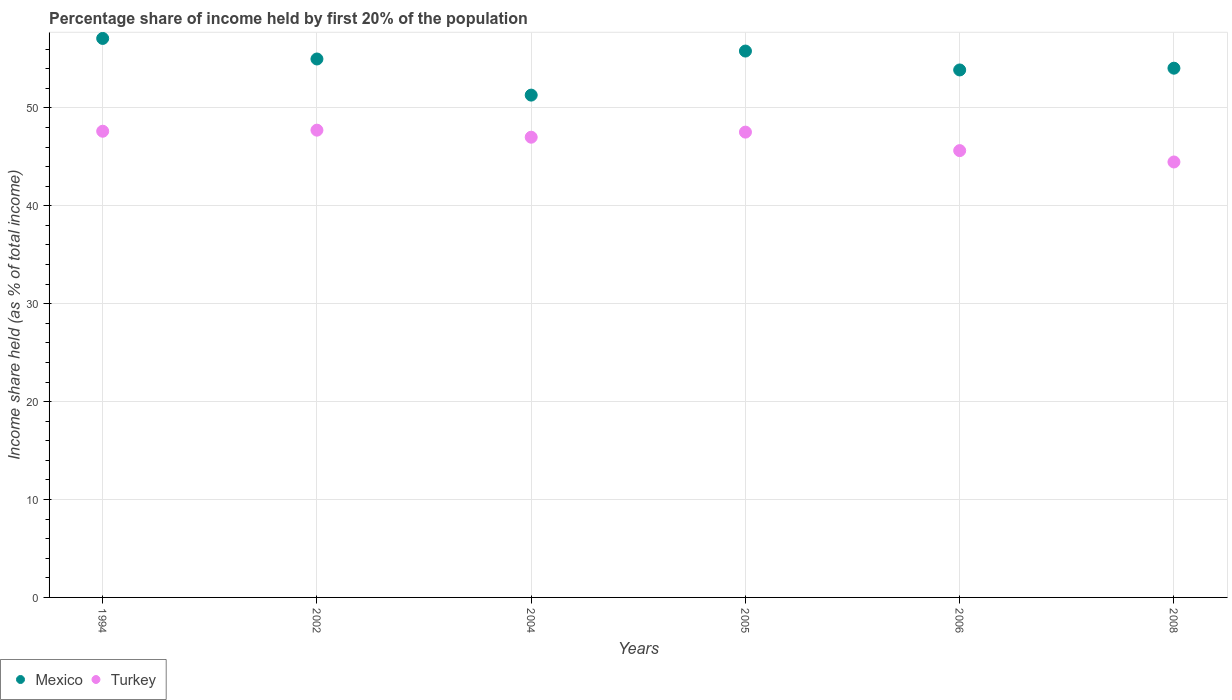Is the number of dotlines equal to the number of legend labels?
Provide a succinct answer. Yes. Across all years, what is the maximum share of income held by first 20% of the population in Turkey?
Ensure brevity in your answer.  47.73. Across all years, what is the minimum share of income held by first 20% of the population in Mexico?
Offer a terse response. 51.31. In which year was the share of income held by first 20% of the population in Turkey maximum?
Your response must be concise. 2002. In which year was the share of income held by first 20% of the population in Turkey minimum?
Your answer should be compact. 2008. What is the total share of income held by first 20% of the population in Mexico in the graph?
Offer a terse response. 327.16. What is the difference between the share of income held by first 20% of the population in Turkey in 1994 and that in 2005?
Make the answer very short. 0.09. What is the difference between the share of income held by first 20% of the population in Mexico in 2002 and the share of income held by first 20% of the population in Turkey in 1994?
Provide a succinct answer. 7.38. What is the average share of income held by first 20% of the population in Turkey per year?
Provide a short and direct response. 46.67. In the year 2006, what is the difference between the share of income held by first 20% of the population in Turkey and share of income held by first 20% of the population in Mexico?
Your answer should be compact. -8.24. What is the ratio of the share of income held by first 20% of the population in Mexico in 2005 to that in 2006?
Ensure brevity in your answer.  1.04. Is the share of income held by first 20% of the population in Turkey in 2005 less than that in 2006?
Ensure brevity in your answer.  No. Is the difference between the share of income held by first 20% of the population in Turkey in 1994 and 2005 greater than the difference between the share of income held by first 20% of the population in Mexico in 1994 and 2005?
Give a very brief answer. No. What is the difference between the highest and the second highest share of income held by first 20% of the population in Turkey?
Offer a terse response. 0.11. What is the difference between the highest and the lowest share of income held by first 20% of the population in Turkey?
Provide a short and direct response. 3.25. In how many years, is the share of income held by first 20% of the population in Mexico greater than the average share of income held by first 20% of the population in Mexico taken over all years?
Your response must be concise. 3. Is the sum of the share of income held by first 20% of the population in Turkey in 2004 and 2008 greater than the maximum share of income held by first 20% of the population in Mexico across all years?
Your answer should be compact. Yes. Does the share of income held by first 20% of the population in Mexico monotonically increase over the years?
Your response must be concise. No. Is the share of income held by first 20% of the population in Turkey strictly less than the share of income held by first 20% of the population in Mexico over the years?
Your answer should be compact. Yes. How many dotlines are there?
Make the answer very short. 2. How many years are there in the graph?
Ensure brevity in your answer.  6. Are the values on the major ticks of Y-axis written in scientific E-notation?
Your answer should be very brief. No. How are the legend labels stacked?
Your answer should be compact. Horizontal. What is the title of the graph?
Your answer should be compact. Percentage share of income held by first 20% of the population. Does "Congo (Republic)" appear as one of the legend labels in the graph?
Make the answer very short. No. What is the label or title of the Y-axis?
Make the answer very short. Income share held (as % of total income). What is the Income share held (as % of total income) in Mexico in 1994?
Keep it short and to the point. 57.1. What is the Income share held (as % of total income) in Turkey in 1994?
Ensure brevity in your answer.  47.62. What is the Income share held (as % of total income) in Mexico in 2002?
Keep it short and to the point. 55. What is the Income share held (as % of total income) of Turkey in 2002?
Ensure brevity in your answer.  47.73. What is the Income share held (as % of total income) in Mexico in 2004?
Give a very brief answer. 51.31. What is the Income share held (as % of total income) of Turkey in 2004?
Your response must be concise. 47.01. What is the Income share held (as % of total income) of Mexico in 2005?
Make the answer very short. 55.81. What is the Income share held (as % of total income) of Turkey in 2005?
Your answer should be very brief. 47.53. What is the Income share held (as % of total income) of Mexico in 2006?
Keep it short and to the point. 53.88. What is the Income share held (as % of total income) in Turkey in 2006?
Provide a short and direct response. 45.64. What is the Income share held (as % of total income) of Mexico in 2008?
Offer a very short reply. 54.06. What is the Income share held (as % of total income) in Turkey in 2008?
Your answer should be very brief. 44.48. Across all years, what is the maximum Income share held (as % of total income) of Mexico?
Provide a succinct answer. 57.1. Across all years, what is the maximum Income share held (as % of total income) in Turkey?
Your response must be concise. 47.73. Across all years, what is the minimum Income share held (as % of total income) in Mexico?
Ensure brevity in your answer.  51.31. Across all years, what is the minimum Income share held (as % of total income) in Turkey?
Offer a very short reply. 44.48. What is the total Income share held (as % of total income) in Mexico in the graph?
Give a very brief answer. 327.16. What is the total Income share held (as % of total income) of Turkey in the graph?
Provide a short and direct response. 280.01. What is the difference between the Income share held (as % of total income) in Turkey in 1994 and that in 2002?
Your answer should be very brief. -0.11. What is the difference between the Income share held (as % of total income) of Mexico in 1994 and that in 2004?
Offer a very short reply. 5.79. What is the difference between the Income share held (as % of total income) in Turkey in 1994 and that in 2004?
Provide a short and direct response. 0.61. What is the difference between the Income share held (as % of total income) of Mexico in 1994 and that in 2005?
Your answer should be compact. 1.29. What is the difference between the Income share held (as % of total income) of Turkey in 1994 and that in 2005?
Keep it short and to the point. 0.09. What is the difference between the Income share held (as % of total income) in Mexico in 1994 and that in 2006?
Your answer should be very brief. 3.22. What is the difference between the Income share held (as % of total income) of Turkey in 1994 and that in 2006?
Your answer should be very brief. 1.98. What is the difference between the Income share held (as % of total income) in Mexico in 1994 and that in 2008?
Offer a very short reply. 3.04. What is the difference between the Income share held (as % of total income) of Turkey in 1994 and that in 2008?
Keep it short and to the point. 3.14. What is the difference between the Income share held (as % of total income) of Mexico in 2002 and that in 2004?
Your response must be concise. 3.69. What is the difference between the Income share held (as % of total income) in Turkey in 2002 and that in 2004?
Your response must be concise. 0.72. What is the difference between the Income share held (as % of total income) in Mexico in 2002 and that in 2005?
Offer a terse response. -0.81. What is the difference between the Income share held (as % of total income) in Turkey in 2002 and that in 2005?
Provide a short and direct response. 0.2. What is the difference between the Income share held (as % of total income) of Mexico in 2002 and that in 2006?
Offer a very short reply. 1.12. What is the difference between the Income share held (as % of total income) in Turkey in 2002 and that in 2006?
Give a very brief answer. 2.09. What is the difference between the Income share held (as % of total income) of Turkey in 2002 and that in 2008?
Make the answer very short. 3.25. What is the difference between the Income share held (as % of total income) of Turkey in 2004 and that in 2005?
Your answer should be very brief. -0.52. What is the difference between the Income share held (as % of total income) in Mexico in 2004 and that in 2006?
Your answer should be compact. -2.57. What is the difference between the Income share held (as % of total income) in Turkey in 2004 and that in 2006?
Provide a succinct answer. 1.37. What is the difference between the Income share held (as % of total income) of Mexico in 2004 and that in 2008?
Your answer should be very brief. -2.75. What is the difference between the Income share held (as % of total income) of Turkey in 2004 and that in 2008?
Make the answer very short. 2.53. What is the difference between the Income share held (as % of total income) of Mexico in 2005 and that in 2006?
Offer a very short reply. 1.93. What is the difference between the Income share held (as % of total income) in Turkey in 2005 and that in 2006?
Offer a terse response. 1.89. What is the difference between the Income share held (as % of total income) in Turkey in 2005 and that in 2008?
Your answer should be very brief. 3.05. What is the difference between the Income share held (as % of total income) of Mexico in 2006 and that in 2008?
Offer a very short reply. -0.18. What is the difference between the Income share held (as % of total income) in Turkey in 2006 and that in 2008?
Keep it short and to the point. 1.16. What is the difference between the Income share held (as % of total income) of Mexico in 1994 and the Income share held (as % of total income) of Turkey in 2002?
Offer a terse response. 9.37. What is the difference between the Income share held (as % of total income) in Mexico in 1994 and the Income share held (as % of total income) in Turkey in 2004?
Provide a succinct answer. 10.09. What is the difference between the Income share held (as % of total income) in Mexico in 1994 and the Income share held (as % of total income) in Turkey in 2005?
Your answer should be compact. 9.57. What is the difference between the Income share held (as % of total income) in Mexico in 1994 and the Income share held (as % of total income) in Turkey in 2006?
Offer a very short reply. 11.46. What is the difference between the Income share held (as % of total income) of Mexico in 1994 and the Income share held (as % of total income) of Turkey in 2008?
Provide a succinct answer. 12.62. What is the difference between the Income share held (as % of total income) of Mexico in 2002 and the Income share held (as % of total income) of Turkey in 2004?
Keep it short and to the point. 7.99. What is the difference between the Income share held (as % of total income) of Mexico in 2002 and the Income share held (as % of total income) of Turkey in 2005?
Make the answer very short. 7.47. What is the difference between the Income share held (as % of total income) of Mexico in 2002 and the Income share held (as % of total income) of Turkey in 2006?
Offer a terse response. 9.36. What is the difference between the Income share held (as % of total income) of Mexico in 2002 and the Income share held (as % of total income) of Turkey in 2008?
Provide a succinct answer. 10.52. What is the difference between the Income share held (as % of total income) of Mexico in 2004 and the Income share held (as % of total income) of Turkey in 2005?
Your response must be concise. 3.78. What is the difference between the Income share held (as % of total income) of Mexico in 2004 and the Income share held (as % of total income) of Turkey in 2006?
Offer a very short reply. 5.67. What is the difference between the Income share held (as % of total income) in Mexico in 2004 and the Income share held (as % of total income) in Turkey in 2008?
Offer a very short reply. 6.83. What is the difference between the Income share held (as % of total income) of Mexico in 2005 and the Income share held (as % of total income) of Turkey in 2006?
Your answer should be very brief. 10.17. What is the difference between the Income share held (as % of total income) of Mexico in 2005 and the Income share held (as % of total income) of Turkey in 2008?
Your answer should be compact. 11.33. What is the difference between the Income share held (as % of total income) in Mexico in 2006 and the Income share held (as % of total income) in Turkey in 2008?
Provide a short and direct response. 9.4. What is the average Income share held (as % of total income) of Mexico per year?
Your answer should be compact. 54.53. What is the average Income share held (as % of total income) in Turkey per year?
Make the answer very short. 46.67. In the year 1994, what is the difference between the Income share held (as % of total income) in Mexico and Income share held (as % of total income) in Turkey?
Keep it short and to the point. 9.48. In the year 2002, what is the difference between the Income share held (as % of total income) of Mexico and Income share held (as % of total income) of Turkey?
Offer a terse response. 7.27. In the year 2004, what is the difference between the Income share held (as % of total income) of Mexico and Income share held (as % of total income) of Turkey?
Make the answer very short. 4.3. In the year 2005, what is the difference between the Income share held (as % of total income) of Mexico and Income share held (as % of total income) of Turkey?
Ensure brevity in your answer.  8.28. In the year 2006, what is the difference between the Income share held (as % of total income) of Mexico and Income share held (as % of total income) of Turkey?
Make the answer very short. 8.24. In the year 2008, what is the difference between the Income share held (as % of total income) of Mexico and Income share held (as % of total income) of Turkey?
Give a very brief answer. 9.58. What is the ratio of the Income share held (as % of total income) of Mexico in 1994 to that in 2002?
Provide a succinct answer. 1.04. What is the ratio of the Income share held (as % of total income) of Mexico in 1994 to that in 2004?
Make the answer very short. 1.11. What is the ratio of the Income share held (as % of total income) in Mexico in 1994 to that in 2005?
Give a very brief answer. 1.02. What is the ratio of the Income share held (as % of total income) of Turkey in 1994 to that in 2005?
Your answer should be compact. 1. What is the ratio of the Income share held (as % of total income) of Mexico in 1994 to that in 2006?
Make the answer very short. 1.06. What is the ratio of the Income share held (as % of total income) of Turkey in 1994 to that in 2006?
Provide a succinct answer. 1.04. What is the ratio of the Income share held (as % of total income) in Mexico in 1994 to that in 2008?
Make the answer very short. 1.06. What is the ratio of the Income share held (as % of total income) in Turkey in 1994 to that in 2008?
Offer a terse response. 1.07. What is the ratio of the Income share held (as % of total income) in Mexico in 2002 to that in 2004?
Give a very brief answer. 1.07. What is the ratio of the Income share held (as % of total income) of Turkey in 2002 to that in 2004?
Ensure brevity in your answer.  1.02. What is the ratio of the Income share held (as % of total income) in Mexico in 2002 to that in 2005?
Offer a terse response. 0.99. What is the ratio of the Income share held (as % of total income) in Mexico in 2002 to that in 2006?
Offer a terse response. 1.02. What is the ratio of the Income share held (as % of total income) of Turkey in 2002 to that in 2006?
Ensure brevity in your answer.  1.05. What is the ratio of the Income share held (as % of total income) of Mexico in 2002 to that in 2008?
Offer a very short reply. 1.02. What is the ratio of the Income share held (as % of total income) in Turkey in 2002 to that in 2008?
Give a very brief answer. 1.07. What is the ratio of the Income share held (as % of total income) in Mexico in 2004 to that in 2005?
Keep it short and to the point. 0.92. What is the ratio of the Income share held (as % of total income) in Mexico in 2004 to that in 2006?
Your response must be concise. 0.95. What is the ratio of the Income share held (as % of total income) of Turkey in 2004 to that in 2006?
Provide a short and direct response. 1.03. What is the ratio of the Income share held (as % of total income) in Mexico in 2004 to that in 2008?
Ensure brevity in your answer.  0.95. What is the ratio of the Income share held (as % of total income) of Turkey in 2004 to that in 2008?
Provide a short and direct response. 1.06. What is the ratio of the Income share held (as % of total income) of Mexico in 2005 to that in 2006?
Keep it short and to the point. 1.04. What is the ratio of the Income share held (as % of total income) in Turkey in 2005 to that in 2006?
Give a very brief answer. 1.04. What is the ratio of the Income share held (as % of total income) in Mexico in 2005 to that in 2008?
Provide a succinct answer. 1.03. What is the ratio of the Income share held (as % of total income) in Turkey in 2005 to that in 2008?
Provide a short and direct response. 1.07. What is the ratio of the Income share held (as % of total income) in Mexico in 2006 to that in 2008?
Provide a succinct answer. 1. What is the ratio of the Income share held (as % of total income) of Turkey in 2006 to that in 2008?
Give a very brief answer. 1.03. What is the difference between the highest and the second highest Income share held (as % of total income) of Mexico?
Offer a very short reply. 1.29. What is the difference between the highest and the second highest Income share held (as % of total income) in Turkey?
Provide a short and direct response. 0.11. What is the difference between the highest and the lowest Income share held (as % of total income) of Mexico?
Offer a very short reply. 5.79. 